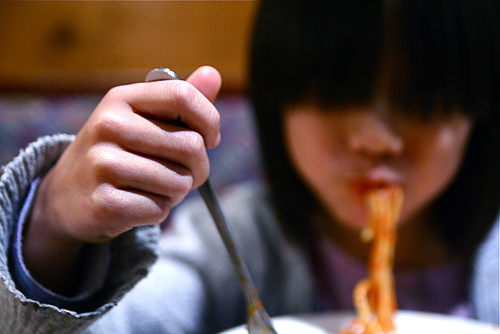<image>
Can you confirm if the noodles is in the person? Yes. The noodles is contained within or inside the person, showing a containment relationship. 